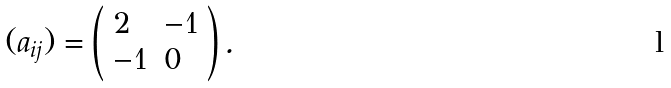<formula> <loc_0><loc_0><loc_500><loc_500>( a _ { i j } ) = \left ( \begin{array} { l l } { 2 } & { - 1 } \\ { - 1 } & { 0 } \end{array} \right ) .</formula> 